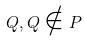Convert formula to latex. <formula><loc_0><loc_0><loc_500><loc_500>Q , Q \notin P</formula> 